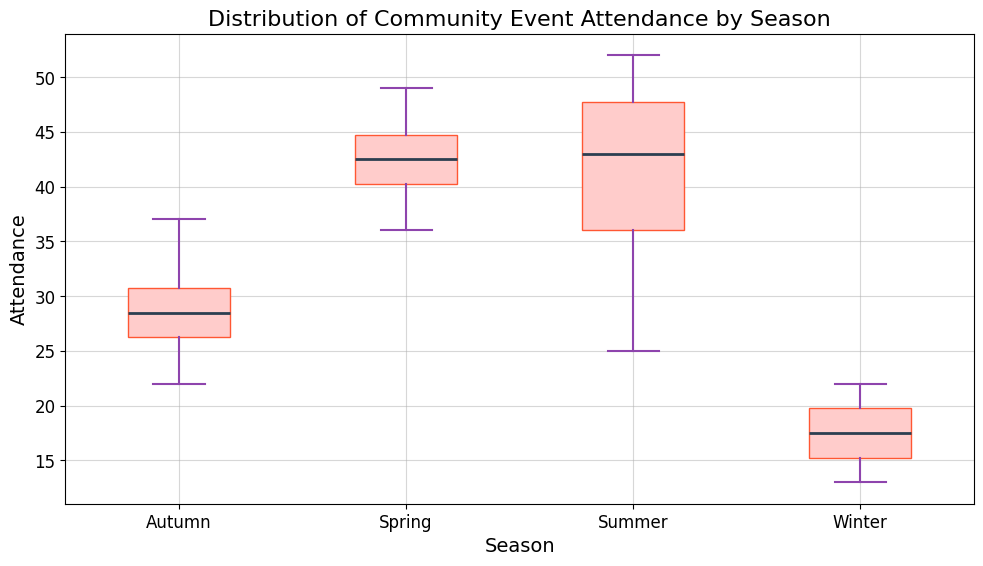What season has the highest median attendance for community events? Examining the box plot, the median line for each season shows that Spring has the highest median attendance compared to other seasons.
Answer: Spring Which season shows the lowest minimum attendance at community events? The minimum attendance is represented by the lower whisker of the box plot for each season. Winter has the lowest minimum attendance.
Answer: Winter Are there any outliers in the attendance data? Outliers are represented by individual points outside the whiskers. There are no outliers visible in the box plots for any season.
Answer: No How does the interquartile range (IQR) of Summer compare to Autumn? The interquartile range is the distance between the lower quartile (Q1) and the upper quartile (Q3). Summer's IQR is larger than Autumn's, as the box (which represents the IQR) for Summer is taller than that of Autumn.
Answer: Summer's IQR is larger than Autumn's Which season has the most consistent attendance, based on the box plot? Consistency in attendance can be inferred from the height of the boxes and the spread of the data. The Winter box plot shows the smallest IQR and the shortest whiskers, indicating the most consistent attendance figures.
Answer: Winter Compare the attendance variability between Spring and Winter. Variability can be assessed by looking at the interquartile range (IQR) and the length of the whiskers. Spring has a larger IQR and longer whiskers than Winter, indicating greater variability in attendance.
Answer: Spring has greater variability What is the difference in the median attendance between Summer and Winter? The median is the line inside each box. The median attendance for Summer is around 43.5, while for Winter it is around 17. The difference is 43.5 - 17 = 26.5.
Answer: 26.5 Which season's attendance has the widest range between the minimum and maximum values? The range is the distance between the smallest and largest value. Summer has the widest range as it has the highest maximum value and a relatively low minimum value compared to other seasons.
Answer: Summer If one were planning an event, which season should be chosen to maximize attendance? Based on the box plot, Spring has the highest median and consistently high attendance values, making it the best choice to maximize attendance.
Answer: Spring 